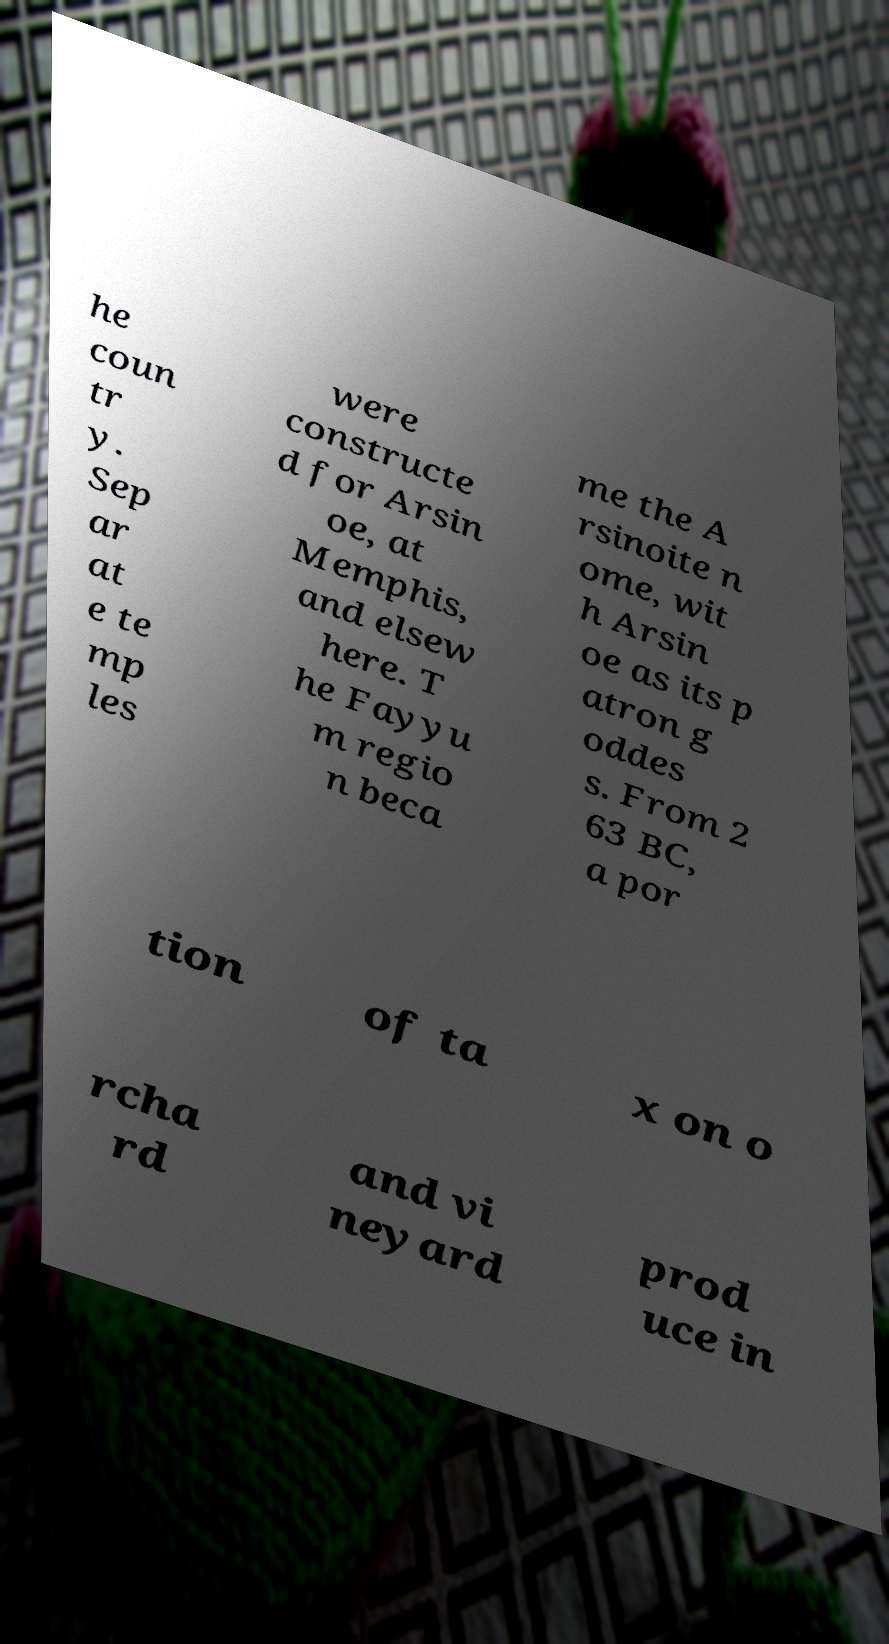Can you read and provide the text displayed in the image?This photo seems to have some interesting text. Can you extract and type it out for me? he coun tr y. Sep ar at e te mp les were constructe d for Arsin oe, at Memphis, and elsew here. T he Fayyu m regio n beca me the A rsinoite n ome, wit h Arsin oe as its p atron g oddes s. From 2 63 BC, a por tion of ta x on o rcha rd and vi neyard prod uce in 